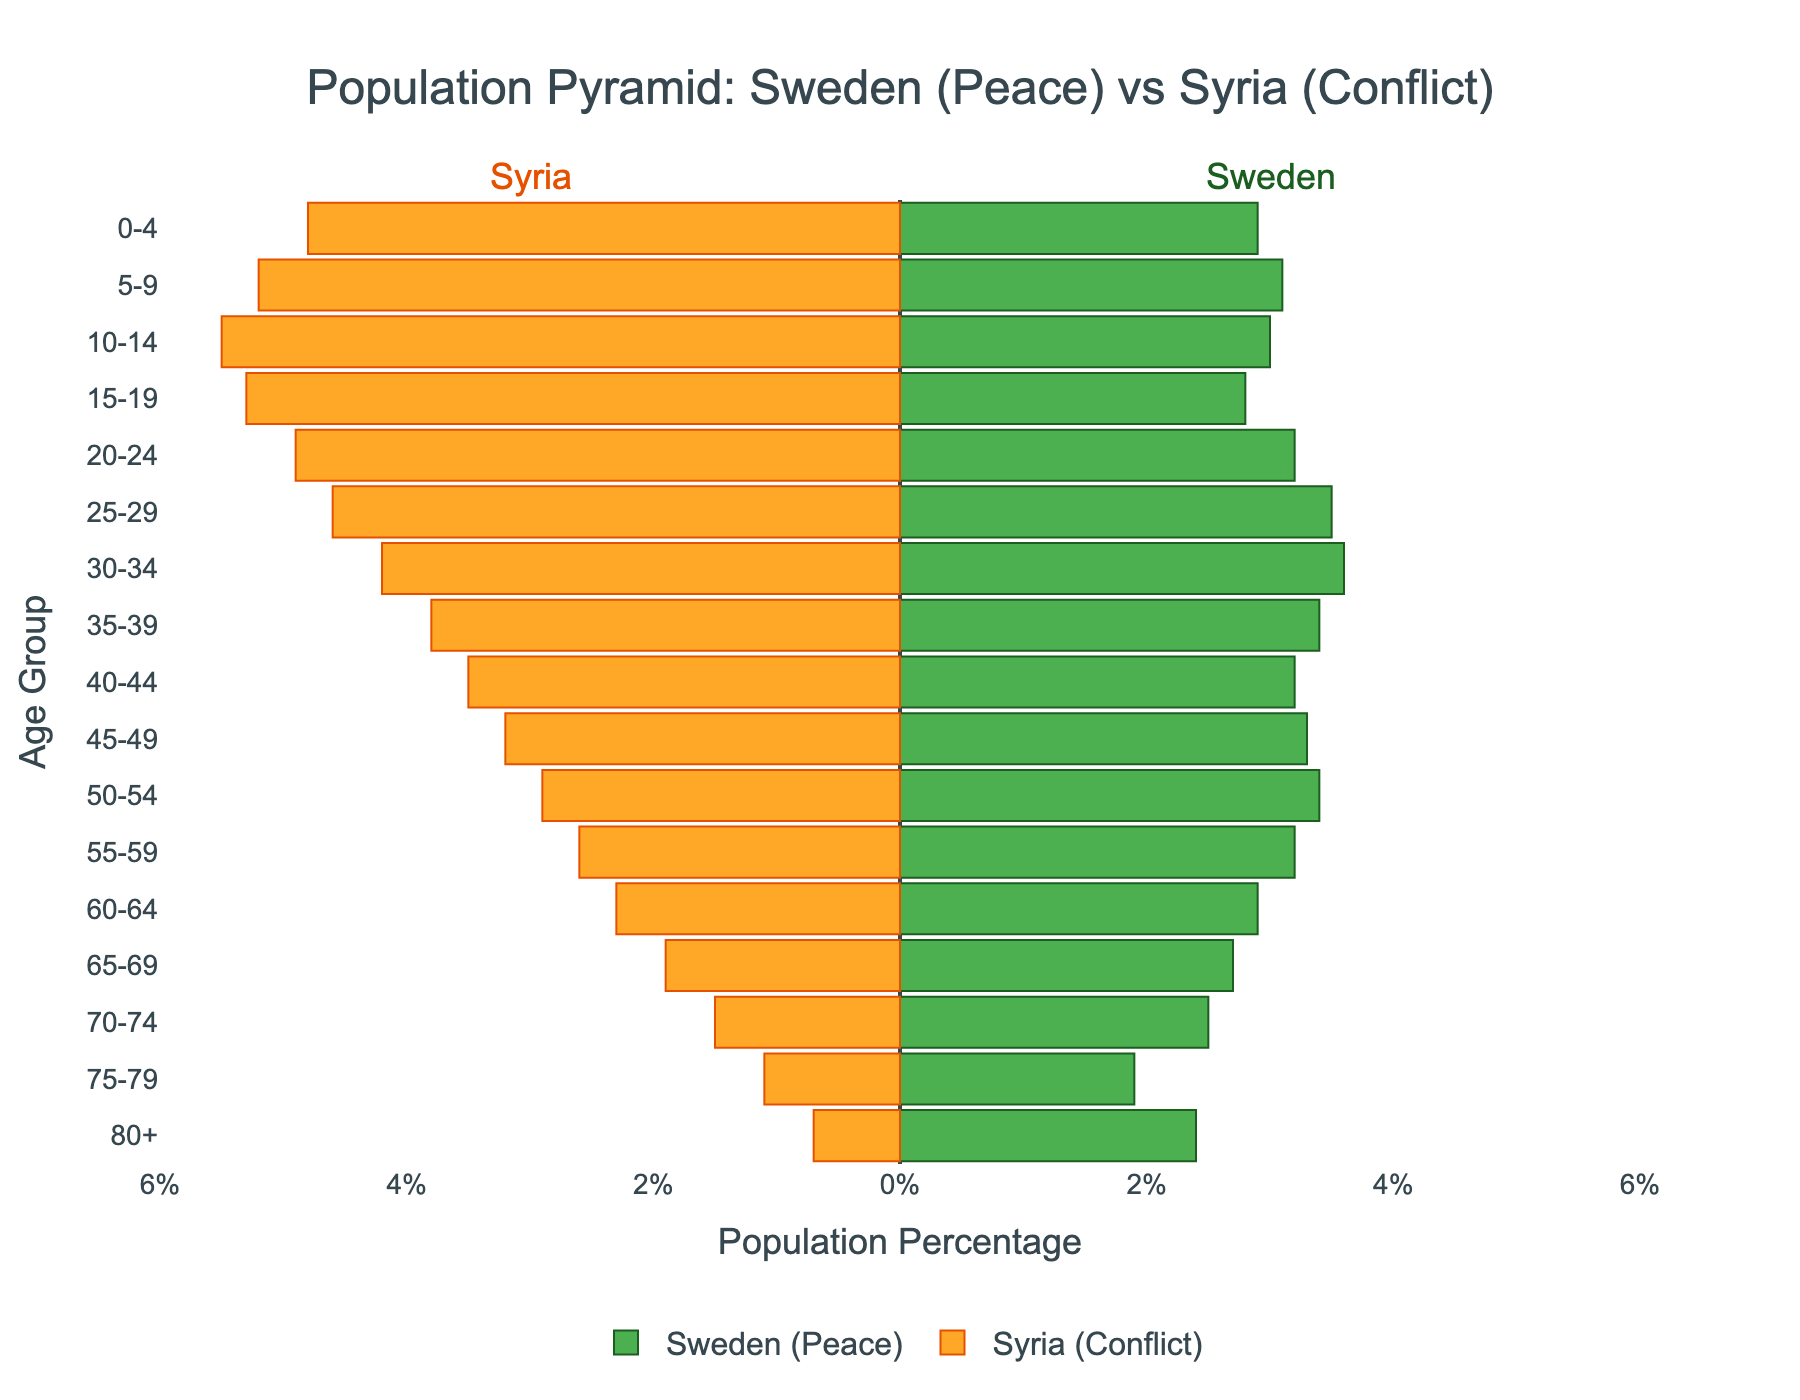What is the title of the figure? The title is usually displayed at the top of the figure. In this case, it reads "Population Pyramid: Sweden (Peace) vs Syria (Conflict)."
Answer: Population Pyramid: Sweden (Peace) vs Syria (Conflict) How are the age groups represented in the figure? Age groups are represented on the y-axis, labeled from oldest at the top to youngest at the bottom. Each group is displayed with horizontal bars indicating population percentages.
Answer: On the y-axis as horizontal bars Which country has a higher population percentage for the age group 0-4? By looking at the bars for the age group 0-4, we can see that Syria (with a value of 4.8%) has a higher population percentage than Sweden (with a value of 2.9%).
Answer: Syria What is the difference in population percentage between Sweden and Syria for the age group 65-69? Syria's value is 1.9%, and Sweden's value is 2.7%. Subtracting these: 2.7% - 1.9% = 0.8%.
Answer: 0.8% Which country shows a larger youth population percentage (0-14 years)? Comparing the sum of values for the age groups 0-4, 5-9, and 10-14: Syria's total is 4.8 + 5.2 + 5.5 = 15.5%, and Sweden's total is 2.9 + 3.1 + 3.0 = 9.0%. Hence, Syria has a larger youth population.
Answer: Syria For which age group do Sweden and Syria have the closest population percentages? Checking each age group's values: the age group 45-49 is closest, with Syria at 3.2% and Sweden at 3.3%, a difference of just 0.1%.
Answer: 45-49 What trend do we observe for Sweden's population percentage as age increases from 0-4 to 80+? Observing Sweden's values shows a general trend of decreasing population percentage with increasing age, except for a slight increase in some older groups.
Answer: Decreasing trend In which age group is Syria's population percentage less than 2%? Reviewing Syria's population percentages: only the age groups 75-79 and 80+ are less than 2% (1.1% and 0.7%, respectively).
Answer: 75-79 and 80+ Which country has a higher elderly population percentage (65+ years)? Considering the sum of values for age groups 65-69, 70-74, 75-79, and 80+: Sweden’s total is 2.7 + 2.5 + 1.9 + 2.4 = 9.5%, while Syria’s total is 1.9 + 1.5 + 1.1 + 0.7 = 5.2%. Sweden has a higher elderly population.
Answer: Sweden 